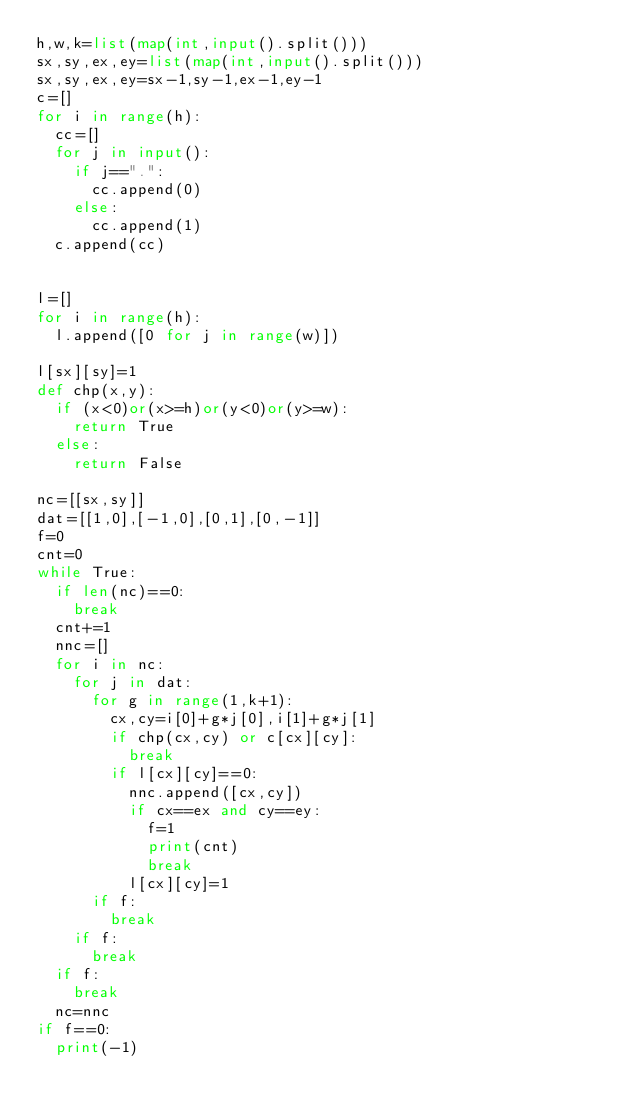Convert code to text. <code><loc_0><loc_0><loc_500><loc_500><_Python_>h,w,k=list(map(int,input().split()))
sx,sy,ex,ey=list(map(int,input().split()))
sx,sy,ex,ey=sx-1,sy-1,ex-1,ey-1
c=[]
for i in range(h):
  cc=[]
  for j in input():
    if j==".":
      cc.append(0)
    else:
      cc.append(1)
  c.append(cc)


l=[]
for i in range(h):
  l.append([0 for j in range(w)])

l[sx][sy]=1
def chp(x,y):
  if (x<0)or(x>=h)or(y<0)or(y>=w):
    return True
  else:
    return False

nc=[[sx,sy]]
dat=[[1,0],[-1,0],[0,1],[0,-1]]
f=0
cnt=0
while True:
  if len(nc)==0:
    break
  cnt+=1
  nnc=[]
  for i in nc:
    for j in dat:
      for g in range(1,k+1):
        cx,cy=i[0]+g*j[0],i[1]+g*j[1]
        if chp(cx,cy) or c[cx][cy]:
          break
        if l[cx][cy]==0:
          nnc.append([cx,cy])
          if cx==ex and cy==ey:
            f=1
            print(cnt)
            break
          l[cx][cy]=1
      if f:
        break
    if f:
      break
  if f:
    break
  nc=nnc
if f==0:
  print(-1)
</code> 